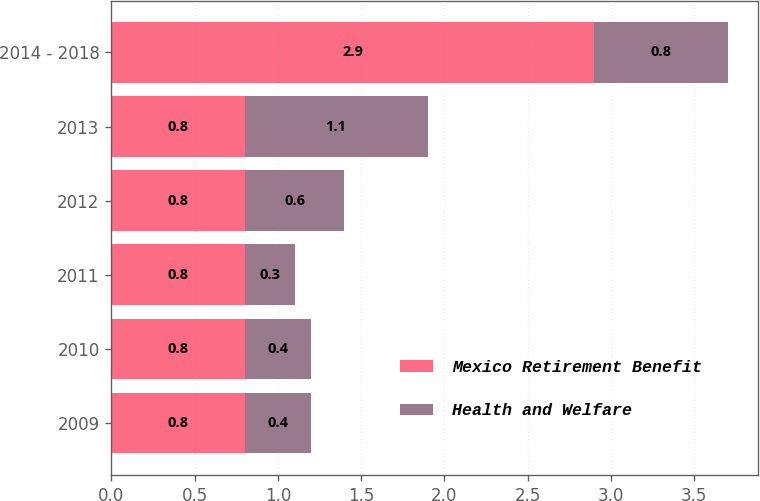<chart> <loc_0><loc_0><loc_500><loc_500><stacked_bar_chart><ecel><fcel>2009<fcel>2010<fcel>2011<fcel>2012<fcel>2013<fcel>2014 - 2018<nl><fcel>Mexico Retirement Benefit<fcel>0.8<fcel>0.8<fcel>0.8<fcel>0.8<fcel>0.8<fcel>2.9<nl><fcel>Health and Welfare<fcel>0.4<fcel>0.4<fcel>0.3<fcel>0.6<fcel>1.1<fcel>0.8<nl></chart> 